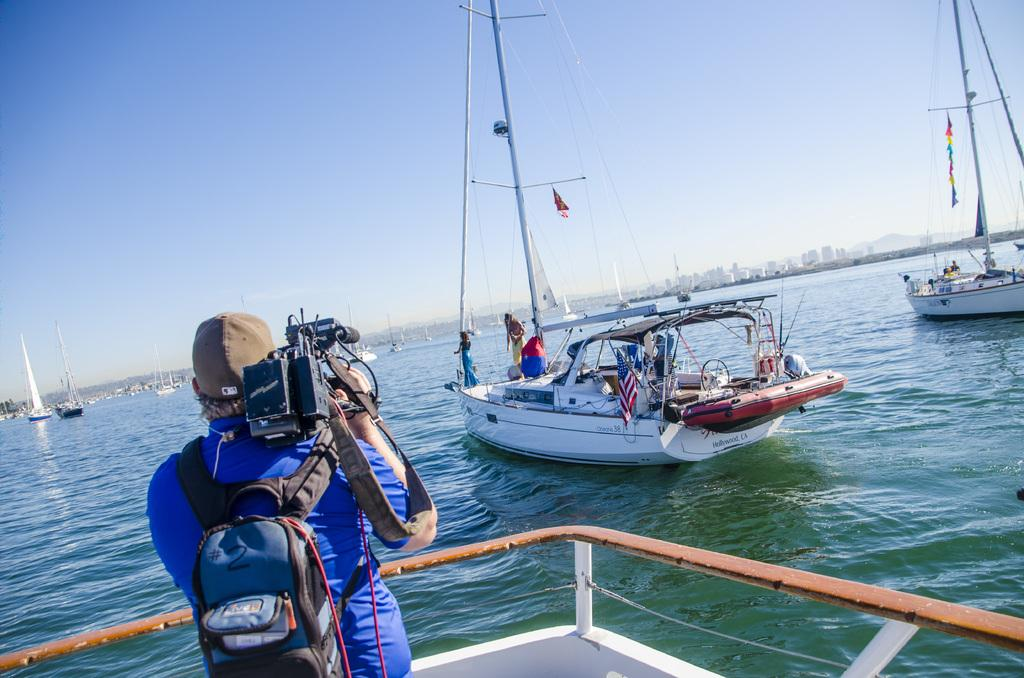What can be seen floating in the water in the image? There are ships floating in the water in the image. What is one person doing in the image? One person is carrying a bag and holding a camera. How many persons are standing in another ship in the image? Two persons are standing in another ship in the image. What type of leather is being used to make the dolls in the image? There are no dolls present in the image, so it is not possible to determine what type of leather might be used. 